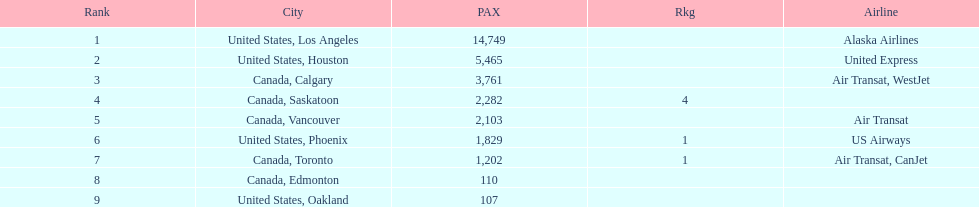What is the average number of passengers in the united states? 5537.5. 